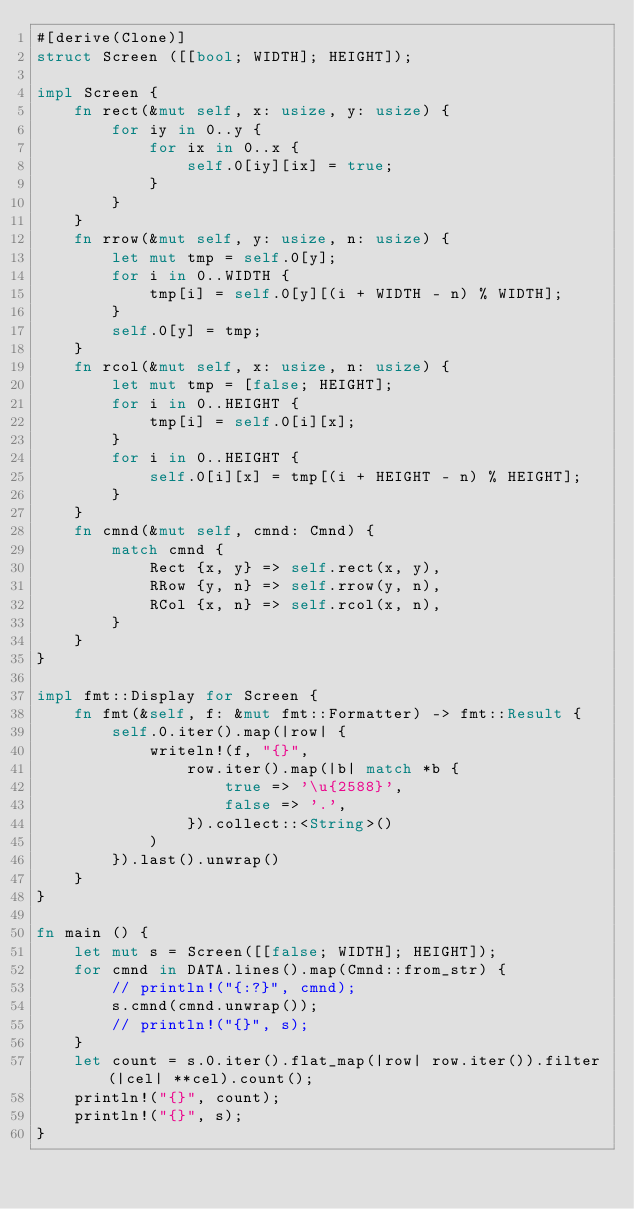Convert code to text. <code><loc_0><loc_0><loc_500><loc_500><_Rust_>#[derive(Clone)]
struct Screen ([[bool; WIDTH]; HEIGHT]);

impl Screen {
    fn rect(&mut self, x: usize, y: usize) {
        for iy in 0..y {
            for ix in 0..x {
                self.0[iy][ix] = true;
            }
        }
    }
    fn rrow(&mut self, y: usize, n: usize) {
        let mut tmp = self.0[y];
        for i in 0..WIDTH {
            tmp[i] = self.0[y][(i + WIDTH - n) % WIDTH];
        }
        self.0[y] = tmp;
    }
    fn rcol(&mut self, x: usize, n: usize) {
        let mut tmp = [false; HEIGHT];
        for i in 0..HEIGHT {
            tmp[i] = self.0[i][x];
        }
        for i in 0..HEIGHT {
            self.0[i][x] = tmp[(i + HEIGHT - n) % HEIGHT];
        }
    }
    fn cmnd(&mut self, cmnd: Cmnd) {
        match cmnd {
            Rect {x, y} => self.rect(x, y),
            RRow {y, n} => self.rrow(y, n),
            RCol {x, n} => self.rcol(x, n),
        }
    }
}

impl fmt::Display for Screen {
    fn fmt(&self, f: &mut fmt::Formatter) -> fmt::Result {
        self.0.iter().map(|row| {
            writeln!(f, "{}",
                row.iter().map(|b| match *b {
                    true => '\u{2588}',
                    false => '.',
                }).collect::<String>()
            )
        }).last().unwrap()
    }
}

fn main () {
    let mut s = Screen([[false; WIDTH]; HEIGHT]);
    for cmnd in DATA.lines().map(Cmnd::from_str) {
        // println!("{:?}", cmnd);
        s.cmnd(cmnd.unwrap());
        // println!("{}", s);
    }
    let count = s.0.iter().flat_map(|row| row.iter()).filter(|cel| **cel).count();
    println!("{}", count);
    println!("{}", s);
}
</code> 